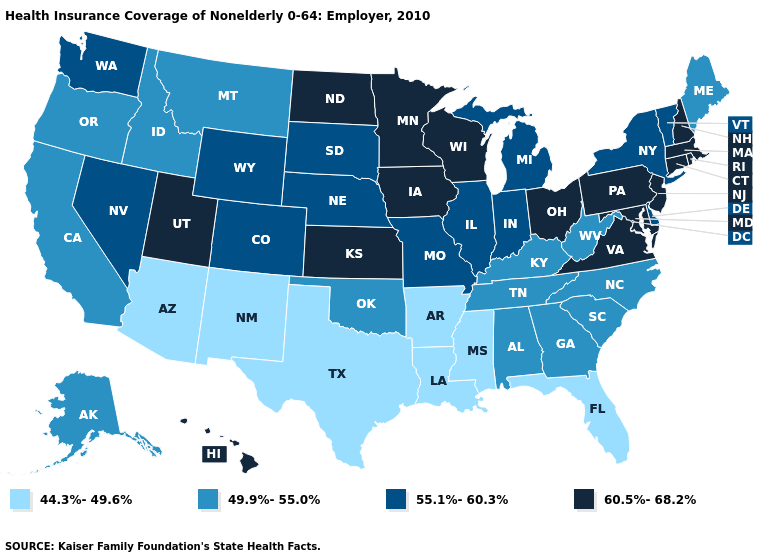Name the states that have a value in the range 60.5%-68.2%?
Write a very short answer. Connecticut, Hawaii, Iowa, Kansas, Maryland, Massachusetts, Minnesota, New Hampshire, New Jersey, North Dakota, Ohio, Pennsylvania, Rhode Island, Utah, Virginia, Wisconsin. Among the states that border Georgia , does South Carolina have the lowest value?
Keep it brief. No. What is the lowest value in the West?
Quick response, please. 44.3%-49.6%. What is the highest value in the USA?
Answer briefly. 60.5%-68.2%. What is the value of Minnesota?
Short answer required. 60.5%-68.2%. Among the states that border Washington , which have the lowest value?
Quick response, please. Idaho, Oregon. Name the states that have a value in the range 55.1%-60.3%?
Answer briefly. Colorado, Delaware, Illinois, Indiana, Michigan, Missouri, Nebraska, Nevada, New York, South Dakota, Vermont, Washington, Wyoming. What is the value of Missouri?
Keep it brief. 55.1%-60.3%. Is the legend a continuous bar?
Concise answer only. No. What is the value of Connecticut?
Give a very brief answer. 60.5%-68.2%. What is the highest value in the Northeast ?
Give a very brief answer. 60.5%-68.2%. What is the lowest value in the Northeast?
Short answer required. 49.9%-55.0%. What is the highest value in states that border New Jersey?
Answer briefly. 60.5%-68.2%. What is the lowest value in states that border North Carolina?
Concise answer only. 49.9%-55.0%. Which states have the lowest value in the USA?
Quick response, please. Arizona, Arkansas, Florida, Louisiana, Mississippi, New Mexico, Texas. 